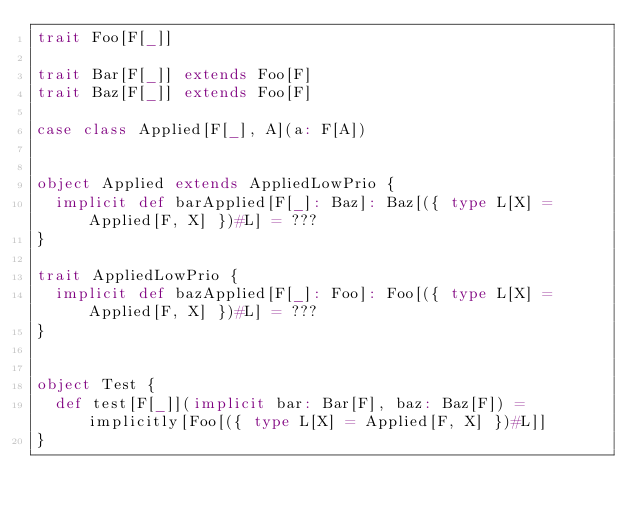Convert code to text. <code><loc_0><loc_0><loc_500><loc_500><_Scala_>trait Foo[F[_]]

trait Bar[F[_]] extends Foo[F]
trait Baz[F[_]] extends Foo[F]

case class Applied[F[_], A](a: F[A])


object Applied extends AppliedLowPrio {
  implicit def barApplied[F[_]: Baz]: Baz[({ type L[X] = Applied[F, X] })#L] = ???
}

trait AppliedLowPrio {
  implicit def bazApplied[F[_]: Foo]: Foo[({ type L[X] = Applied[F, X] })#L] = ???
}


object Test {
  def test[F[_]](implicit bar: Bar[F], baz: Baz[F]) = implicitly[Foo[({ type L[X] = Applied[F, X] })#L]]
}
</code> 